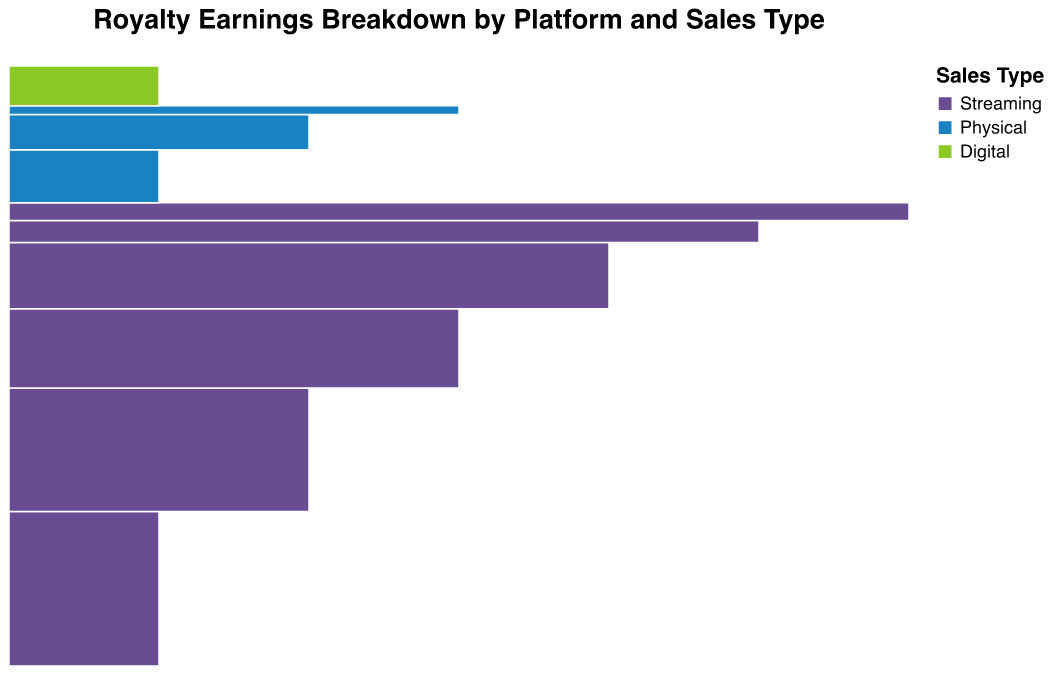What are the three types of sales in the plot? To answer this, look at the color legend provided in the plot. The legend helps to distinguish between the categories.
Answer: Streaming, Physical, Digital Which streaming platform has the highest earnings? Identify the largest section within the color representing Streaming. According to the plot, the platform with the largest earnings will have the largest section in that color.
Answer: Spotify How do the earnings from Vinyl compare to those from CDs? Locate the sections for Vinyl and CDs within the color representing Physical. Compare their sizes or use the tooltip to compare their earnings directly.
Answer: Vinyl has higher earnings than CDs What is the total earnings from physical sales? Sum the earnings from all the sections within the color representing Physical. The physical sales include Vinyl, CDs, and Cassettes.
Answer: 220,000 Which sales type contributes the least to overall earnings? Compare the total sizes of the sections representing Streaming, Physical, and Digital sales. The smallest total size indicates the least contribution.
Answer: Digital What is the difference in earnings between Apple Music and Amazon Music? Identify the sections for Apple Music and Amazon Music within the Streaming color. Use the tooltip to determine their earnings and find the difference.
Answer: 100,000 How many platforms are classified under digital sales? Check the sections within the Digital color and count the number of distinct platform names.
Answer: 1 What percentage of total earnings comes from Spotify? Determine Spotify’s earnings and find the total earnings by summing all earnings from all platforms. Then calculate the percentage.
Answer: 27.56% Which is the least earning platform among the streaming services? Identify the smallest section within the Streaming color. Use the tooltip to determine the earnings.
Answer: Pandora How do the combined earnings from Amazon Music and YouTube Music compare to Apple Music? Sum the earnings from Amazon Music and YouTube Music, then compare this sum to Apple Music’s earnings.
Answer: Slightly higher than Apple Music 